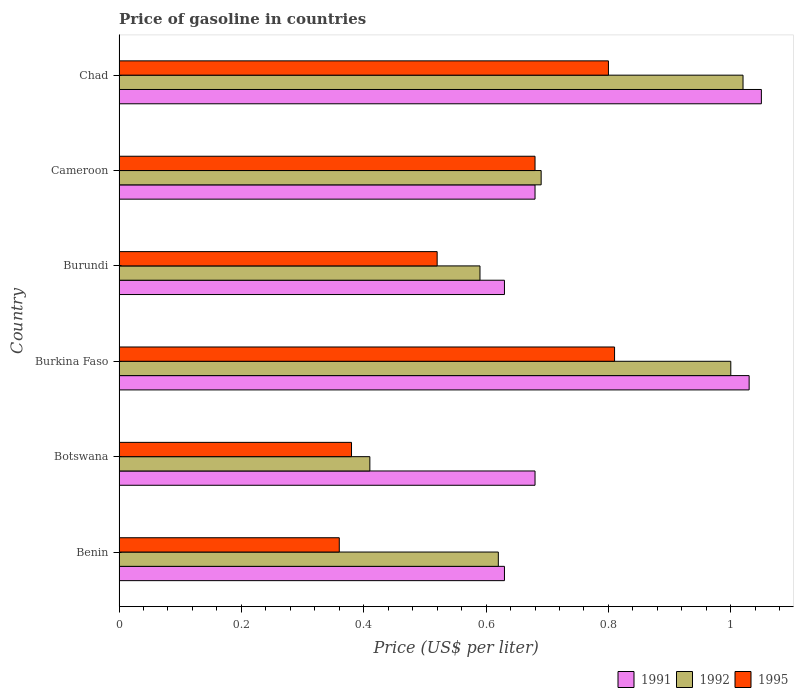How many different coloured bars are there?
Provide a short and direct response. 3. Are the number of bars per tick equal to the number of legend labels?
Offer a terse response. Yes. How many bars are there on the 1st tick from the top?
Your answer should be compact. 3. What is the label of the 3rd group of bars from the top?
Make the answer very short. Burundi. What is the price of gasoline in 1991 in Cameroon?
Make the answer very short. 0.68. Across all countries, what is the minimum price of gasoline in 1995?
Your response must be concise. 0.36. In which country was the price of gasoline in 1992 maximum?
Provide a succinct answer. Chad. In which country was the price of gasoline in 1991 minimum?
Your answer should be very brief. Benin. What is the total price of gasoline in 1991 in the graph?
Give a very brief answer. 4.7. What is the difference between the price of gasoline in 1992 in Burkina Faso and that in Burundi?
Provide a short and direct response. 0.41. What is the difference between the price of gasoline in 1992 in Cameroon and the price of gasoline in 1995 in Botswana?
Offer a very short reply. 0.31. What is the average price of gasoline in 1995 per country?
Provide a short and direct response. 0.59. What is the difference between the price of gasoline in 1995 and price of gasoline in 1991 in Botswana?
Your response must be concise. -0.3. What is the ratio of the price of gasoline in 1995 in Benin to that in Burkina Faso?
Ensure brevity in your answer.  0.44. Is the price of gasoline in 1995 in Benin less than that in Burkina Faso?
Make the answer very short. Yes. What is the difference between the highest and the second highest price of gasoline in 1995?
Offer a terse response. 0.01. What is the difference between the highest and the lowest price of gasoline in 1992?
Make the answer very short. 0.61. In how many countries, is the price of gasoline in 1995 greater than the average price of gasoline in 1995 taken over all countries?
Keep it short and to the point. 3. What does the 3rd bar from the top in Burkina Faso represents?
Your response must be concise. 1991. How many bars are there?
Ensure brevity in your answer.  18. What is the difference between two consecutive major ticks on the X-axis?
Provide a succinct answer. 0.2. Does the graph contain any zero values?
Offer a terse response. No. How are the legend labels stacked?
Offer a very short reply. Horizontal. What is the title of the graph?
Keep it short and to the point. Price of gasoline in countries. What is the label or title of the X-axis?
Offer a terse response. Price (US$ per liter). What is the label or title of the Y-axis?
Ensure brevity in your answer.  Country. What is the Price (US$ per liter) of 1991 in Benin?
Keep it short and to the point. 0.63. What is the Price (US$ per liter) of 1992 in Benin?
Provide a succinct answer. 0.62. What is the Price (US$ per liter) in 1995 in Benin?
Make the answer very short. 0.36. What is the Price (US$ per liter) in 1991 in Botswana?
Ensure brevity in your answer.  0.68. What is the Price (US$ per liter) of 1992 in Botswana?
Keep it short and to the point. 0.41. What is the Price (US$ per liter) of 1995 in Botswana?
Make the answer very short. 0.38. What is the Price (US$ per liter) of 1991 in Burkina Faso?
Your answer should be very brief. 1.03. What is the Price (US$ per liter) in 1995 in Burkina Faso?
Offer a terse response. 0.81. What is the Price (US$ per liter) of 1991 in Burundi?
Give a very brief answer. 0.63. What is the Price (US$ per liter) in 1992 in Burundi?
Offer a very short reply. 0.59. What is the Price (US$ per liter) of 1995 in Burundi?
Provide a short and direct response. 0.52. What is the Price (US$ per liter) in 1991 in Cameroon?
Provide a short and direct response. 0.68. What is the Price (US$ per liter) in 1992 in Cameroon?
Keep it short and to the point. 0.69. What is the Price (US$ per liter) in 1995 in Cameroon?
Offer a terse response. 0.68. What is the Price (US$ per liter) of 1991 in Chad?
Offer a very short reply. 1.05. What is the Price (US$ per liter) of 1992 in Chad?
Your answer should be very brief. 1.02. Across all countries, what is the maximum Price (US$ per liter) of 1992?
Make the answer very short. 1.02. Across all countries, what is the maximum Price (US$ per liter) of 1995?
Ensure brevity in your answer.  0.81. Across all countries, what is the minimum Price (US$ per liter) in 1991?
Ensure brevity in your answer.  0.63. Across all countries, what is the minimum Price (US$ per liter) of 1992?
Your answer should be very brief. 0.41. Across all countries, what is the minimum Price (US$ per liter) of 1995?
Offer a very short reply. 0.36. What is the total Price (US$ per liter) in 1991 in the graph?
Provide a short and direct response. 4.7. What is the total Price (US$ per liter) in 1992 in the graph?
Offer a terse response. 4.33. What is the total Price (US$ per liter) of 1995 in the graph?
Give a very brief answer. 3.55. What is the difference between the Price (US$ per liter) in 1991 in Benin and that in Botswana?
Make the answer very short. -0.05. What is the difference between the Price (US$ per liter) of 1992 in Benin and that in Botswana?
Offer a terse response. 0.21. What is the difference between the Price (US$ per liter) in 1995 in Benin and that in Botswana?
Give a very brief answer. -0.02. What is the difference between the Price (US$ per liter) of 1992 in Benin and that in Burkina Faso?
Give a very brief answer. -0.38. What is the difference between the Price (US$ per liter) of 1995 in Benin and that in Burkina Faso?
Provide a succinct answer. -0.45. What is the difference between the Price (US$ per liter) in 1991 in Benin and that in Burundi?
Your answer should be very brief. 0. What is the difference between the Price (US$ per liter) in 1995 in Benin and that in Burundi?
Keep it short and to the point. -0.16. What is the difference between the Price (US$ per liter) in 1991 in Benin and that in Cameroon?
Your answer should be very brief. -0.05. What is the difference between the Price (US$ per liter) in 1992 in Benin and that in Cameroon?
Offer a very short reply. -0.07. What is the difference between the Price (US$ per liter) of 1995 in Benin and that in Cameroon?
Provide a short and direct response. -0.32. What is the difference between the Price (US$ per liter) in 1991 in Benin and that in Chad?
Provide a succinct answer. -0.42. What is the difference between the Price (US$ per liter) in 1995 in Benin and that in Chad?
Make the answer very short. -0.44. What is the difference between the Price (US$ per liter) of 1991 in Botswana and that in Burkina Faso?
Give a very brief answer. -0.35. What is the difference between the Price (US$ per liter) of 1992 in Botswana and that in Burkina Faso?
Give a very brief answer. -0.59. What is the difference between the Price (US$ per liter) in 1995 in Botswana and that in Burkina Faso?
Give a very brief answer. -0.43. What is the difference between the Price (US$ per liter) of 1991 in Botswana and that in Burundi?
Keep it short and to the point. 0.05. What is the difference between the Price (US$ per liter) of 1992 in Botswana and that in Burundi?
Give a very brief answer. -0.18. What is the difference between the Price (US$ per liter) in 1995 in Botswana and that in Burundi?
Provide a short and direct response. -0.14. What is the difference between the Price (US$ per liter) in 1991 in Botswana and that in Cameroon?
Ensure brevity in your answer.  0. What is the difference between the Price (US$ per liter) in 1992 in Botswana and that in Cameroon?
Your answer should be very brief. -0.28. What is the difference between the Price (US$ per liter) of 1995 in Botswana and that in Cameroon?
Your response must be concise. -0.3. What is the difference between the Price (US$ per liter) of 1991 in Botswana and that in Chad?
Offer a terse response. -0.37. What is the difference between the Price (US$ per liter) of 1992 in Botswana and that in Chad?
Provide a short and direct response. -0.61. What is the difference between the Price (US$ per liter) of 1995 in Botswana and that in Chad?
Your answer should be compact. -0.42. What is the difference between the Price (US$ per liter) of 1992 in Burkina Faso and that in Burundi?
Make the answer very short. 0.41. What is the difference between the Price (US$ per liter) in 1995 in Burkina Faso and that in Burundi?
Provide a short and direct response. 0.29. What is the difference between the Price (US$ per liter) of 1991 in Burkina Faso and that in Cameroon?
Offer a terse response. 0.35. What is the difference between the Price (US$ per liter) in 1992 in Burkina Faso and that in Cameroon?
Ensure brevity in your answer.  0.31. What is the difference between the Price (US$ per liter) of 1995 in Burkina Faso and that in Cameroon?
Give a very brief answer. 0.13. What is the difference between the Price (US$ per liter) of 1991 in Burkina Faso and that in Chad?
Keep it short and to the point. -0.02. What is the difference between the Price (US$ per liter) of 1992 in Burkina Faso and that in Chad?
Keep it short and to the point. -0.02. What is the difference between the Price (US$ per liter) in 1995 in Burkina Faso and that in Chad?
Give a very brief answer. 0.01. What is the difference between the Price (US$ per liter) in 1995 in Burundi and that in Cameroon?
Give a very brief answer. -0.16. What is the difference between the Price (US$ per liter) of 1991 in Burundi and that in Chad?
Offer a very short reply. -0.42. What is the difference between the Price (US$ per liter) in 1992 in Burundi and that in Chad?
Your answer should be very brief. -0.43. What is the difference between the Price (US$ per liter) in 1995 in Burundi and that in Chad?
Keep it short and to the point. -0.28. What is the difference between the Price (US$ per liter) of 1991 in Cameroon and that in Chad?
Your response must be concise. -0.37. What is the difference between the Price (US$ per liter) of 1992 in Cameroon and that in Chad?
Offer a terse response. -0.33. What is the difference between the Price (US$ per liter) in 1995 in Cameroon and that in Chad?
Give a very brief answer. -0.12. What is the difference between the Price (US$ per liter) in 1991 in Benin and the Price (US$ per liter) in 1992 in Botswana?
Your answer should be very brief. 0.22. What is the difference between the Price (US$ per liter) in 1991 in Benin and the Price (US$ per liter) in 1995 in Botswana?
Ensure brevity in your answer.  0.25. What is the difference between the Price (US$ per liter) of 1992 in Benin and the Price (US$ per liter) of 1995 in Botswana?
Provide a short and direct response. 0.24. What is the difference between the Price (US$ per liter) in 1991 in Benin and the Price (US$ per liter) in 1992 in Burkina Faso?
Offer a terse response. -0.37. What is the difference between the Price (US$ per liter) of 1991 in Benin and the Price (US$ per liter) of 1995 in Burkina Faso?
Ensure brevity in your answer.  -0.18. What is the difference between the Price (US$ per liter) in 1992 in Benin and the Price (US$ per liter) in 1995 in Burkina Faso?
Your answer should be very brief. -0.19. What is the difference between the Price (US$ per liter) of 1991 in Benin and the Price (US$ per liter) of 1992 in Burundi?
Your answer should be compact. 0.04. What is the difference between the Price (US$ per liter) in 1991 in Benin and the Price (US$ per liter) in 1995 in Burundi?
Ensure brevity in your answer.  0.11. What is the difference between the Price (US$ per liter) of 1992 in Benin and the Price (US$ per liter) of 1995 in Burundi?
Provide a succinct answer. 0.1. What is the difference between the Price (US$ per liter) in 1991 in Benin and the Price (US$ per liter) in 1992 in Cameroon?
Offer a terse response. -0.06. What is the difference between the Price (US$ per liter) of 1992 in Benin and the Price (US$ per liter) of 1995 in Cameroon?
Provide a short and direct response. -0.06. What is the difference between the Price (US$ per liter) in 1991 in Benin and the Price (US$ per liter) in 1992 in Chad?
Your answer should be compact. -0.39. What is the difference between the Price (US$ per liter) in 1991 in Benin and the Price (US$ per liter) in 1995 in Chad?
Ensure brevity in your answer.  -0.17. What is the difference between the Price (US$ per liter) of 1992 in Benin and the Price (US$ per liter) of 1995 in Chad?
Offer a terse response. -0.18. What is the difference between the Price (US$ per liter) in 1991 in Botswana and the Price (US$ per liter) in 1992 in Burkina Faso?
Make the answer very short. -0.32. What is the difference between the Price (US$ per liter) in 1991 in Botswana and the Price (US$ per liter) in 1995 in Burkina Faso?
Keep it short and to the point. -0.13. What is the difference between the Price (US$ per liter) of 1992 in Botswana and the Price (US$ per liter) of 1995 in Burkina Faso?
Your answer should be very brief. -0.4. What is the difference between the Price (US$ per liter) in 1991 in Botswana and the Price (US$ per liter) in 1992 in Burundi?
Ensure brevity in your answer.  0.09. What is the difference between the Price (US$ per liter) in 1991 in Botswana and the Price (US$ per liter) in 1995 in Burundi?
Provide a succinct answer. 0.16. What is the difference between the Price (US$ per liter) of 1992 in Botswana and the Price (US$ per liter) of 1995 in Burundi?
Keep it short and to the point. -0.11. What is the difference between the Price (US$ per liter) of 1991 in Botswana and the Price (US$ per liter) of 1992 in Cameroon?
Keep it short and to the point. -0.01. What is the difference between the Price (US$ per liter) in 1992 in Botswana and the Price (US$ per liter) in 1995 in Cameroon?
Offer a very short reply. -0.27. What is the difference between the Price (US$ per liter) in 1991 in Botswana and the Price (US$ per liter) in 1992 in Chad?
Provide a succinct answer. -0.34. What is the difference between the Price (US$ per liter) of 1991 in Botswana and the Price (US$ per liter) of 1995 in Chad?
Provide a short and direct response. -0.12. What is the difference between the Price (US$ per liter) of 1992 in Botswana and the Price (US$ per liter) of 1995 in Chad?
Offer a very short reply. -0.39. What is the difference between the Price (US$ per liter) of 1991 in Burkina Faso and the Price (US$ per liter) of 1992 in Burundi?
Make the answer very short. 0.44. What is the difference between the Price (US$ per liter) in 1991 in Burkina Faso and the Price (US$ per liter) in 1995 in Burundi?
Keep it short and to the point. 0.51. What is the difference between the Price (US$ per liter) of 1992 in Burkina Faso and the Price (US$ per liter) of 1995 in Burundi?
Keep it short and to the point. 0.48. What is the difference between the Price (US$ per liter) of 1991 in Burkina Faso and the Price (US$ per liter) of 1992 in Cameroon?
Offer a terse response. 0.34. What is the difference between the Price (US$ per liter) of 1991 in Burkina Faso and the Price (US$ per liter) of 1995 in Cameroon?
Ensure brevity in your answer.  0.35. What is the difference between the Price (US$ per liter) of 1992 in Burkina Faso and the Price (US$ per liter) of 1995 in Cameroon?
Keep it short and to the point. 0.32. What is the difference between the Price (US$ per liter) in 1991 in Burkina Faso and the Price (US$ per liter) in 1995 in Chad?
Your answer should be compact. 0.23. What is the difference between the Price (US$ per liter) in 1991 in Burundi and the Price (US$ per liter) in 1992 in Cameroon?
Make the answer very short. -0.06. What is the difference between the Price (US$ per liter) of 1992 in Burundi and the Price (US$ per liter) of 1995 in Cameroon?
Your answer should be very brief. -0.09. What is the difference between the Price (US$ per liter) of 1991 in Burundi and the Price (US$ per liter) of 1992 in Chad?
Provide a short and direct response. -0.39. What is the difference between the Price (US$ per liter) of 1991 in Burundi and the Price (US$ per liter) of 1995 in Chad?
Offer a terse response. -0.17. What is the difference between the Price (US$ per liter) in 1992 in Burundi and the Price (US$ per liter) in 1995 in Chad?
Ensure brevity in your answer.  -0.21. What is the difference between the Price (US$ per liter) of 1991 in Cameroon and the Price (US$ per liter) of 1992 in Chad?
Offer a terse response. -0.34. What is the difference between the Price (US$ per liter) of 1991 in Cameroon and the Price (US$ per liter) of 1995 in Chad?
Ensure brevity in your answer.  -0.12. What is the difference between the Price (US$ per liter) in 1992 in Cameroon and the Price (US$ per liter) in 1995 in Chad?
Offer a very short reply. -0.11. What is the average Price (US$ per liter) in 1991 per country?
Offer a terse response. 0.78. What is the average Price (US$ per liter) of 1992 per country?
Your answer should be very brief. 0.72. What is the average Price (US$ per liter) of 1995 per country?
Give a very brief answer. 0.59. What is the difference between the Price (US$ per liter) of 1991 and Price (US$ per liter) of 1995 in Benin?
Provide a succinct answer. 0.27. What is the difference between the Price (US$ per liter) in 1992 and Price (US$ per liter) in 1995 in Benin?
Provide a succinct answer. 0.26. What is the difference between the Price (US$ per liter) in 1991 and Price (US$ per liter) in 1992 in Botswana?
Provide a short and direct response. 0.27. What is the difference between the Price (US$ per liter) of 1991 and Price (US$ per liter) of 1995 in Burkina Faso?
Keep it short and to the point. 0.22. What is the difference between the Price (US$ per liter) in 1992 and Price (US$ per liter) in 1995 in Burkina Faso?
Your response must be concise. 0.19. What is the difference between the Price (US$ per liter) of 1991 and Price (US$ per liter) of 1995 in Burundi?
Offer a terse response. 0.11. What is the difference between the Price (US$ per liter) of 1992 and Price (US$ per liter) of 1995 in Burundi?
Your answer should be compact. 0.07. What is the difference between the Price (US$ per liter) in 1991 and Price (US$ per liter) in 1992 in Cameroon?
Give a very brief answer. -0.01. What is the difference between the Price (US$ per liter) in 1991 and Price (US$ per liter) in 1995 in Cameroon?
Ensure brevity in your answer.  0. What is the difference between the Price (US$ per liter) of 1992 and Price (US$ per liter) of 1995 in Cameroon?
Your response must be concise. 0.01. What is the difference between the Price (US$ per liter) in 1991 and Price (US$ per liter) in 1992 in Chad?
Provide a succinct answer. 0.03. What is the difference between the Price (US$ per liter) of 1991 and Price (US$ per liter) of 1995 in Chad?
Provide a succinct answer. 0.25. What is the difference between the Price (US$ per liter) of 1992 and Price (US$ per liter) of 1995 in Chad?
Your answer should be very brief. 0.22. What is the ratio of the Price (US$ per liter) of 1991 in Benin to that in Botswana?
Give a very brief answer. 0.93. What is the ratio of the Price (US$ per liter) in 1992 in Benin to that in Botswana?
Provide a short and direct response. 1.51. What is the ratio of the Price (US$ per liter) in 1995 in Benin to that in Botswana?
Offer a very short reply. 0.95. What is the ratio of the Price (US$ per liter) of 1991 in Benin to that in Burkina Faso?
Ensure brevity in your answer.  0.61. What is the ratio of the Price (US$ per liter) in 1992 in Benin to that in Burkina Faso?
Offer a very short reply. 0.62. What is the ratio of the Price (US$ per liter) of 1995 in Benin to that in Burkina Faso?
Provide a succinct answer. 0.44. What is the ratio of the Price (US$ per liter) in 1991 in Benin to that in Burundi?
Provide a short and direct response. 1. What is the ratio of the Price (US$ per liter) in 1992 in Benin to that in Burundi?
Provide a short and direct response. 1.05. What is the ratio of the Price (US$ per liter) of 1995 in Benin to that in Burundi?
Give a very brief answer. 0.69. What is the ratio of the Price (US$ per liter) of 1991 in Benin to that in Cameroon?
Offer a terse response. 0.93. What is the ratio of the Price (US$ per liter) of 1992 in Benin to that in Cameroon?
Keep it short and to the point. 0.9. What is the ratio of the Price (US$ per liter) in 1995 in Benin to that in Cameroon?
Your answer should be very brief. 0.53. What is the ratio of the Price (US$ per liter) in 1991 in Benin to that in Chad?
Your answer should be very brief. 0.6. What is the ratio of the Price (US$ per liter) in 1992 in Benin to that in Chad?
Make the answer very short. 0.61. What is the ratio of the Price (US$ per liter) in 1995 in Benin to that in Chad?
Your response must be concise. 0.45. What is the ratio of the Price (US$ per liter) of 1991 in Botswana to that in Burkina Faso?
Offer a very short reply. 0.66. What is the ratio of the Price (US$ per liter) in 1992 in Botswana to that in Burkina Faso?
Offer a very short reply. 0.41. What is the ratio of the Price (US$ per liter) in 1995 in Botswana to that in Burkina Faso?
Offer a terse response. 0.47. What is the ratio of the Price (US$ per liter) of 1991 in Botswana to that in Burundi?
Provide a short and direct response. 1.08. What is the ratio of the Price (US$ per liter) of 1992 in Botswana to that in Burundi?
Offer a terse response. 0.69. What is the ratio of the Price (US$ per liter) in 1995 in Botswana to that in Burundi?
Offer a very short reply. 0.73. What is the ratio of the Price (US$ per liter) in 1991 in Botswana to that in Cameroon?
Provide a succinct answer. 1. What is the ratio of the Price (US$ per liter) in 1992 in Botswana to that in Cameroon?
Your response must be concise. 0.59. What is the ratio of the Price (US$ per liter) in 1995 in Botswana to that in Cameroon?
Give a very brief answer. 0.56. What is the ratio of the Price (US$ per liter) of 1991 in Botswana to that in Chad?
Give a very brief answer. 0.65. What is the ratio of the Price (US$ per liter) in 1992 in Botswana to that in Chad?
Offer a terse response. 0.4. What is the ratio of the Price (US$ per liter) of 1995 in Botswana to that in Chad?
Give a very brief answer. 0.47. What is the ratio of the Price (US$ per liter) of 1991 in Burkina Faso to that in Burundi?
Your response must be concise. 1.63. What is the ratio of the Price (US$ per liter) of 1992 in Burkina Faso to that in Burundi?
Provide a short and direct response. 1.69. What is the ratio of the Price (US$ per liter) of 1995 in Burkina Faso to that in Burundi?
Keep it short and to the point. 1.56. What is the ratio of the Price (US$ per liter) in 1991 in Burkina Faso to that in Cameroon?
Your answer should be very brief. 1.51. What is the ratio of the Price (US$ per liter) of 1992 in Burkina Faso to that in Cameroon?
Your response must be concise. 1.45. What is the ratio of the Price (US$ per liter) of 1995 in Burkina Faso to that in Cameroon?
Ensure brevity in your answer.  1.19. What is the ratio of the Price (US$ per liter) of 1992 in Burkina Faso to that in Chad?
Provide a short and direct response. 0.98. What is the ratio of the Price (US$ per liter) of 1995 in Burkina Faso to that in Chad?
Your answer should be compact. 1.01. What is the ratio of the Price (US$ per liter) of 1991 in Burundi to that in Cameroon?
Your response must be concise. 0.93. What is the ratio of the Price (US$ per liter) in 1992 in Burundi to that in Cameroon?
Offer a terse response. 0.86. What is the ratio of the Price (US$ per liter) of 1995 in Burundi to that in Cameroon?
Offer a terse response. 0.76. What is the ratio of the Price (US$ per liter) in 1992 in Burundi to that in Chad?
Provide a short and direct response. 0.58. What is the ratio of the Price (US$ per liter) in 1995 in Burundi to that in Chad?
Offer a very short reply. 0.65. What is the ratio of the Price (US$ per liter) in 1991 in Cameroon to that in Chad?
Offer a very short reply. 0.65. What is the ratio of the Price (US$ per liter) in 1992 in Cameroon to that in Chad?
Offer a terse response. 0.68. What is the ratio of the Price (US$ per liter) in 1995 in Cameroon to that in Chad?
Make the answer very short. 0.85. What is the difference between the highest and the second highest Price (US$ per liter) of 1992?
Your answer should be compact. 0.02. What is the difference between the highest and the second highest Price (US$ per liter) of 1995?
Give a very brief answer. 0.01. What is the difference between the highest and the lowest Price (US$ per liter) of 1991?
Your answer should be very brief. 0.42. What is the difference between the highest and the lowest Price (US$ per liter) of 1992?
Provide a succinct answer. 0.61. What is the difference between the highest and the lowest Price (US$ per liter) of 1995?
Ensure brevity in your answer.  0.45. 